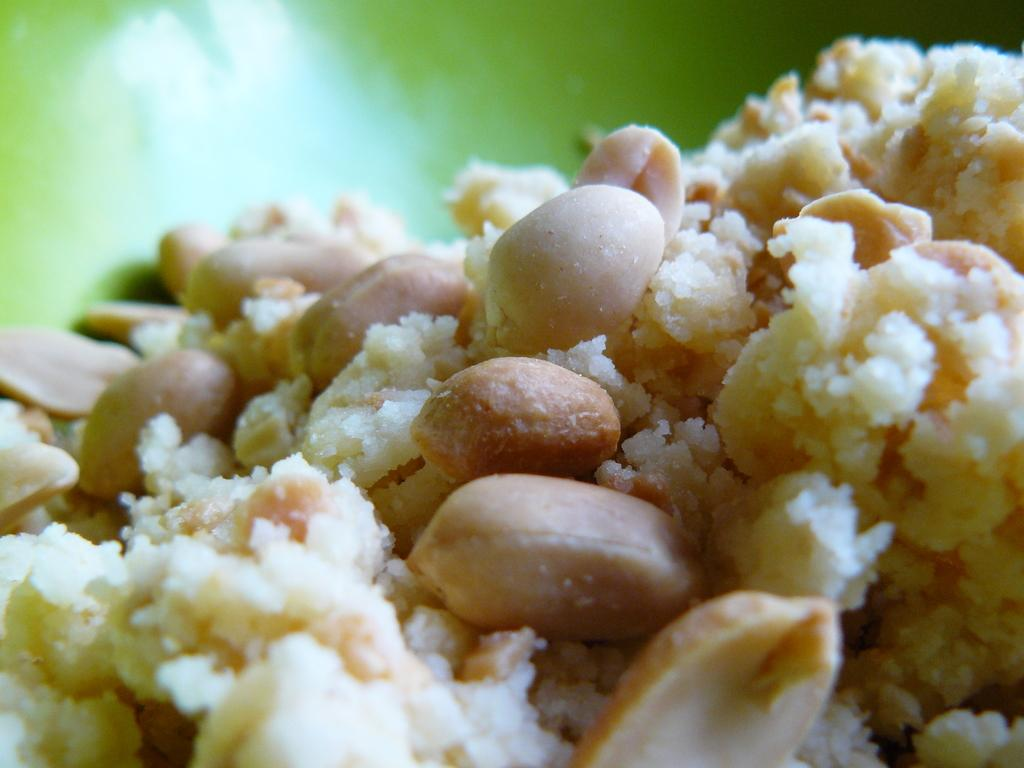What is the main subject of the picture? The main subject of the picture is a food item. What type of ingredient can be seen in the picture? Ground nuts are present in the picture. What color is the plate on which the food item is placed? The food item is placed on a green color plate. What type of cream is being used by the sister in the image? There is no sister or cream present in the image; it only features a food item with ground nuts on a green plate. 